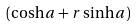Convert formula to latex. <formula><loc_0><loc_0><loc_500><loc_500>( \cosh { a } + r \sinh { a } )</formula> 